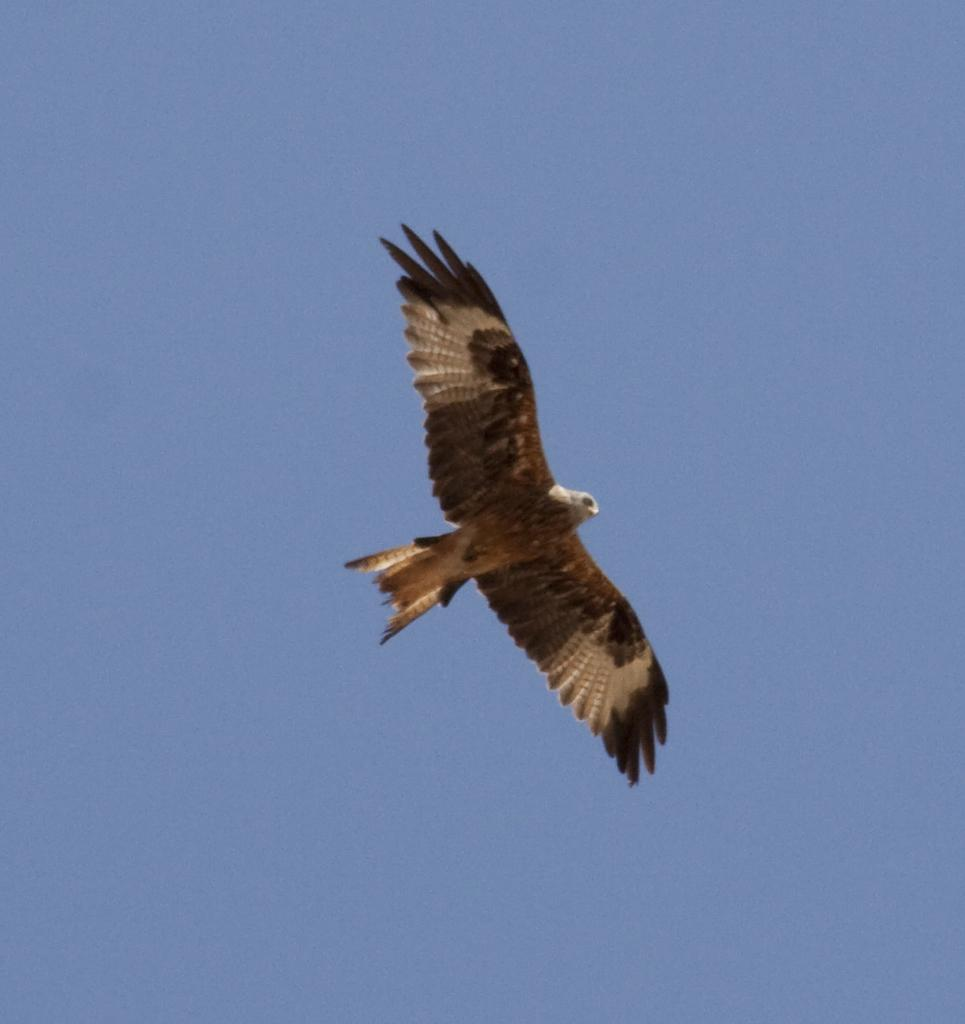What type of animal can be seen in the sky in the image? There is a bird in the sky in the image. What type of badge can be seen on the bird's skin in the image? There is no badge or skin visible on the bird in the image, as it is a bird flying in the sky. Can you tell me how many rabbits are present in the image? There are no rabbits present in the image; it features a bird in the sky. 